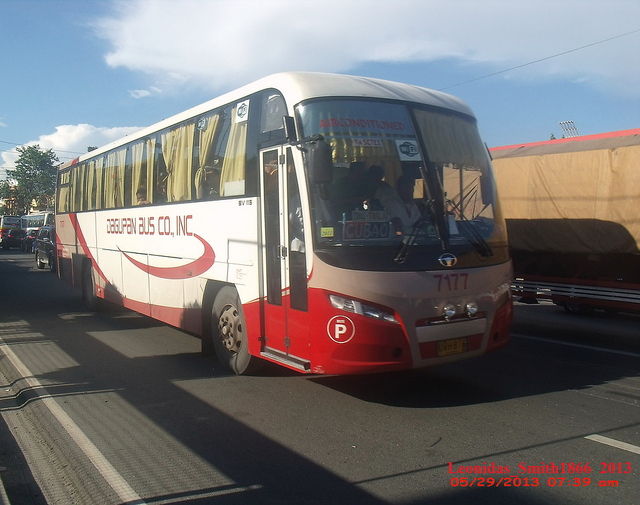Please identify all text content in this image. CUBAO 7177 am 39 07 2013 29 05 2013 Smith1866 Leonidas P .INC CO 205 